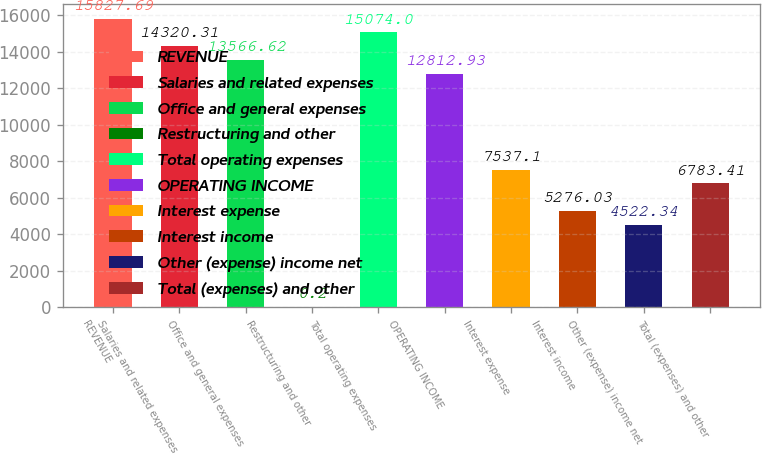Convert chart. <chart><loc_0><loc_0><loc_500><loc_500><bar_chart><fcel>REVENUE<fcel>Salaries and related expenses<fcel>Office and general expenses<fcel>Restructuring and other<fcel>Total operating expenses<fcel>OPERATING INCOME<fcel>Interest expense<fcel>Interest income<fcel>Other (expense) income net<fcel>Total (expenses) and other<nl><fcel>15827.7<fcel>14320.3<fcel>13566.6<fcel>0.2<fcel>15074<fcel>12812.9<fcel>7537.1<fcel>5276.03<fcel>4522.34<fcel>6783.41<nl></chart> 